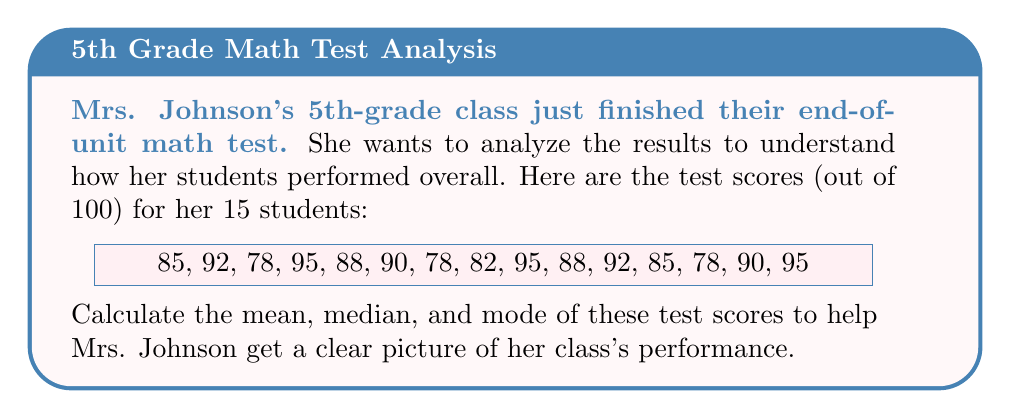What is the answer to this math problem? Let's calculate the mean, median, and mode step by step:

1. Mean:
   The mean is the average of all scores.
   
   Sum of all scores: 85 + 92 + 78 + 95 + 88 + 90 + 78 + 82 + 95 + 88 + 92 + 85 + 78 + 90 + 95 = 1311
   Number of students: 15
   
   Mean = $\frac{\text{Sum of all scores}}{\text{Number of students}} = \frac{1311}{15} = 87.4$

2. Median:
   The median is the middle value when the scores are arranged in order.
   
   Arranged scores: 78, 78, 78, 82, 85, 85, 88, 88, 90, 90, 92, 92, 95, 95, 95
   
   With 15 scores, the median is the 8th score.
   
   Median = 88

3. Mode:
   The mode is the score that appears most frequently.
   
   78 appears 3 times
   95 appears 3 times
   
   Both 78 and 95 appear most frequently, so there are two modes.
Answer: Mean: 87.4, Median: 88, Mode: 78 and 95 